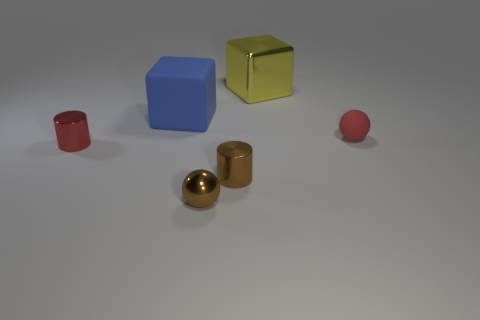How many gray things are large metallic cubes or small rubber spheres?
Provide a succinct answer. 0. What color is the object that is behind the small red matte thing and left of the tiny brown cylinder?
Offer a very short reply. Blue. Does the ball that is behind the red cylinder have the same material as the small ball on the left side of the yellow metallic block?
Give a very brief answer. No. Are there more small red objects behind the metal block than metal things on the left side of the red metallic cylinder?
Give a very brief answer. No. There is a brown thing that is the same size as the brown metallic ball; what shape is it?
Your answer should be compact. Cylinder. What number of things are either matte spheres or metal objects on the left side of the large blue cube?
Your answer should be very brief. 2. Does the shiny cube have the same color as the big matte thing?
Offer a very short reply. No. There is a blue matte object; what number of small red metal cylinders are in front of it?
Make the answer very short. 1. There is a large block that is made of the same material as the red cylinder; what color is it?
Make the answer very short. Yellow. What number of shiny objects are tiny spheres or yellow spheres?
Provide a succinct answer. 1. 